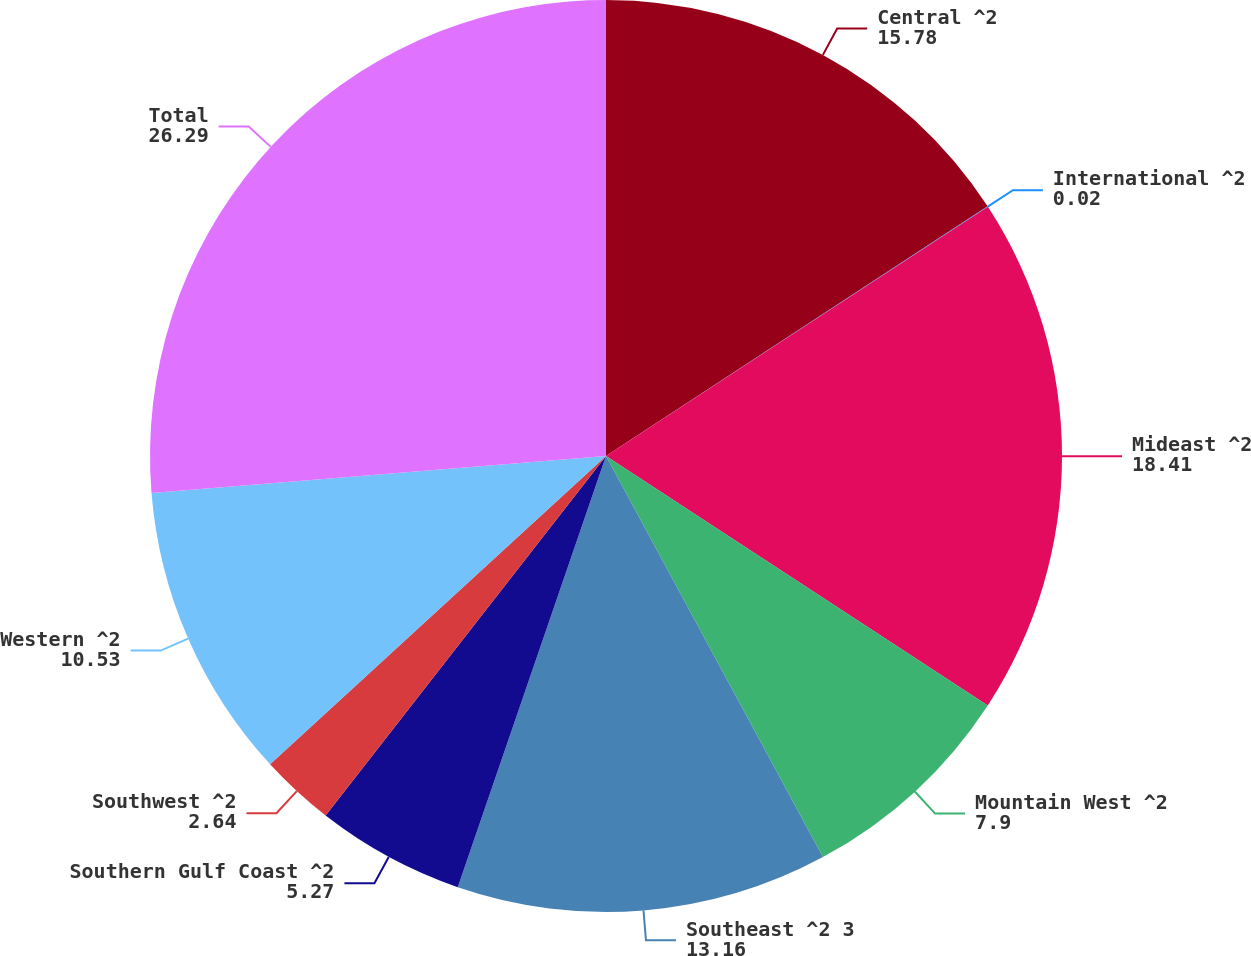<chart> <loc_0><loc_0><loc_500><loc_500><pie_chart><fcel>Central ^2<fcel>International ^2<fcel>Mideast ^2<fcel>Mountain West ^2<fcel>Southeast ^2 3<fcel>Southern Gulf Coast ^2<fcel>Southwest ^2<fcel>Western ^2<fcel>Total<nl><fcel>15.78%<fcel>0.02%<fcel>18.41%<fcel>7.9%<fcel>13.16%<fcel>5.27%<fcel>2.64%<fcel>10.53%<fcel>26.29%<nl></chart> 